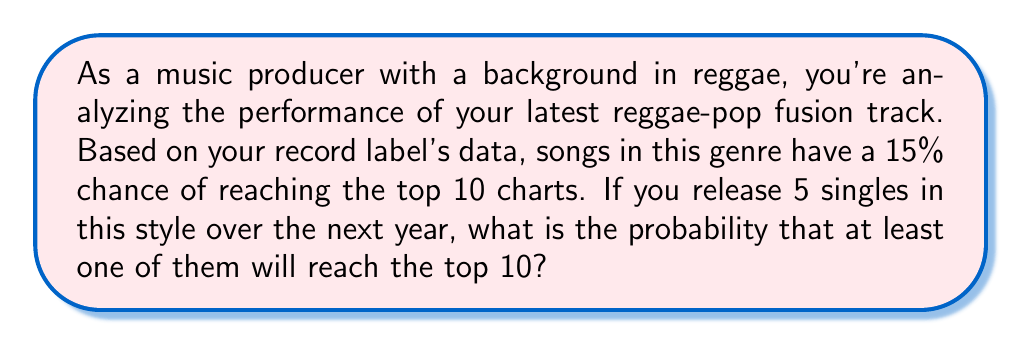Solve this math problem. To solve this problem, we'll use the concept of complementary events and the binomial probability distribution.

1) Let's define our events:
   A: At least one song reaches the top 10
   A': No songs reach the top 10 (complement of A)

2) We're looking for P(A), but it's easier to calculate P(A') and then use:
   P(A) = 1 - P(A')

3) For a single song:
   P(success) = 0.15
   P(failure) = 1 - 0.15 = 0.85

4) For all 5 songs to fail to reach the top 10:
   P(A') = $0.85^5$

5) Now we can calculate P(A):
   P(A) = 1 - P(A')
        = $1 - 0.85^5$
        = $1 - 0.4437$
        = 0.5563

6) Convert to a percentage:
   0.5563 * 100 = 55.63%

Therefore, the probability of at least one song reaching the top 10 is approximately 55.63%.

To verify using the binomial probability formula:

$$P(X \geq 1) = 1 - P(X = 0) = 1 - \binom{5}{0}(0.15)^0(0.85)^5 = 1 - 0.4437 = 0.5563$$

This confirms our earlier calculation.
Answer: The probability that at least one of the five singles will reach the top 10 charts is approximately 55.63%. 